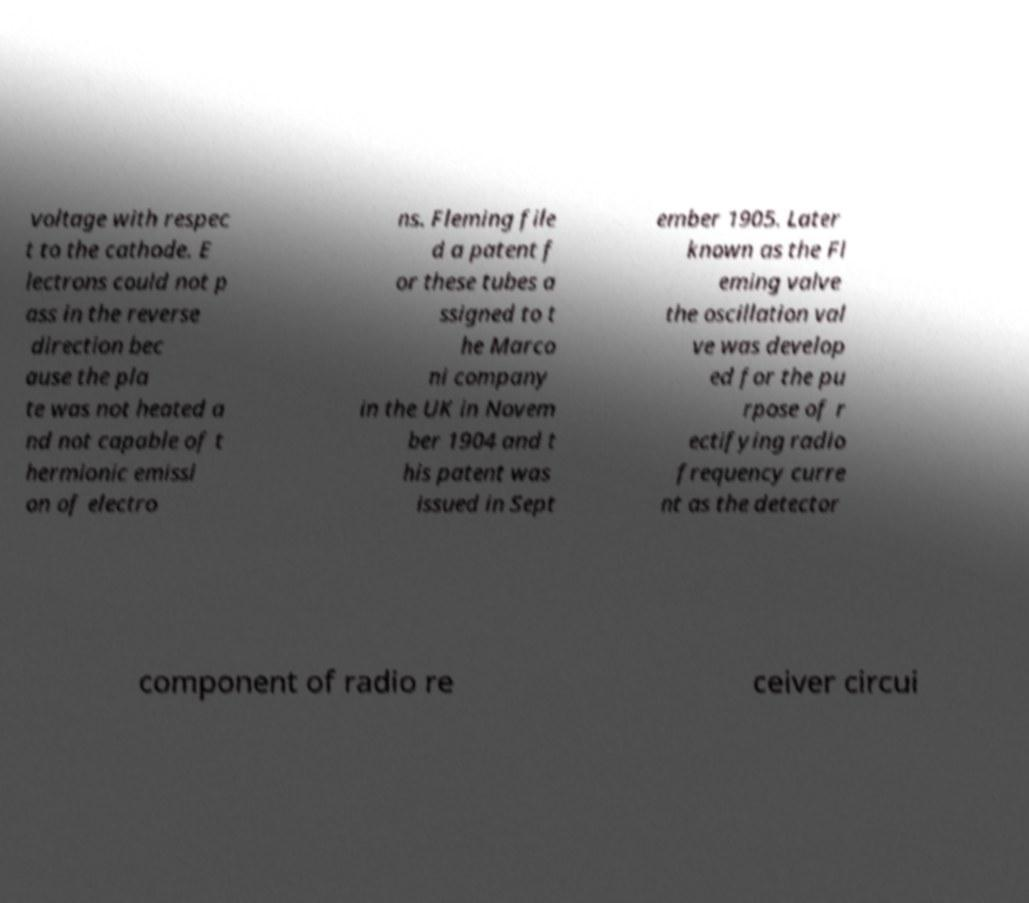Can you accurately transcribe the text from the provided image for me? voltage with respec t to the cathode. E lectrons could not p ass in the reverse direction bec ause the pla te was not heated a nd not capable of t hermionic emissi on of electro ns. Fleming file d a patent f or these tubes a ssigned to t he Marco ni company in the UK in Novem ber 1904 and t his patent was issued in Sept ember 1905. Later known as the Fl eming valve the oscillation val ve was develop ed for the pu rpose of r ectifying radio frequency curre nt as the detector component of radio re ceiver circui 